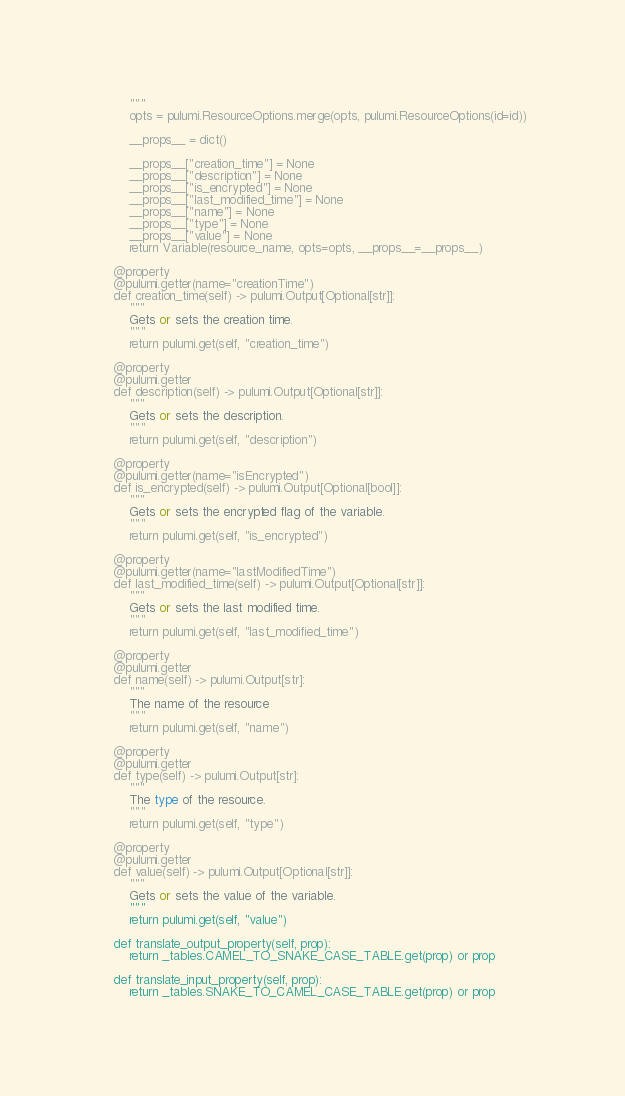<code> <loc_0><loc_0><loc_500><loc_500><_Python_>        """
        opts = pulumi.ResourceOptions.merge(opts, pulumi.ResourceOptions(id=id))

        __props__ = dict()

        __props__["creation_time"] = None
        __props__["description"] = None
        __props__["is_encrypted"] = None
        __props__["last_modified_time"] = None
        __props__["name"] = None
        __props__["type"] = None
        __props__["value"] = None
        return Variable(resource_name, opts=opts, __props__=__props__)

    @property
    @pulumi.getter(name="creationTime")
    def creation_time(self) -> pulumi.Output[Optional[str]]:
        """
        Gets or sets the creation time.
        """
        return pulumi.get(self, "creation_time")

    @property
    @pulumi.getter
    def description(self) -> pulumi.Output[Optional[str]]:
        """
        Gets or sets the description.
        """
        return pulumi.get(self, "description")

    @property
    @pulumi.getter(name="isEncrypted")
    def is_encrypted(self) -> pulumi.Output[Optional[bool]]:
        """
        Gets or sets the encrypted flag of the variable.
        """
        return pulumi.get(self, "is_encrypted")

    @property
    @pulumi.getter(name="lastModifiedTime")
    def last_modified_time(self) -> pulumi.Output[Optional[str]]:
        """
        Gets or sets the last modified time.
        """
        return pulumi.get(self, "last_modified_time")

    @property
    @pulumi.getter
    def name(self) -> pulumi.Output[str]:
        """
        The name of the resource
        """
        return pulumi.get(self, "name")

    @property
    @pulumi.getter
    def type(self) -> pulumi.Output[str]:
        """
        The type of the resource.
        """
        return pulumi.get(self, "type")

    @property
    @pulumi.getter
    def value(self) -> pulumi.Output[Optional[str]]:
        """
        Gets or sets the value of the variable.
        """
        return pulumi.get(self, "value")

    def translate_output_property(self, prop):
        return _tables.CAMEL_TO_SNAKE_CASE_TABLE.get(prop) or prop

    def translate_input_property(self, prop):
        return _tables.SNAKE_TO_CAMEL_CASE_TABLE.get(prop) or prop

</code> 